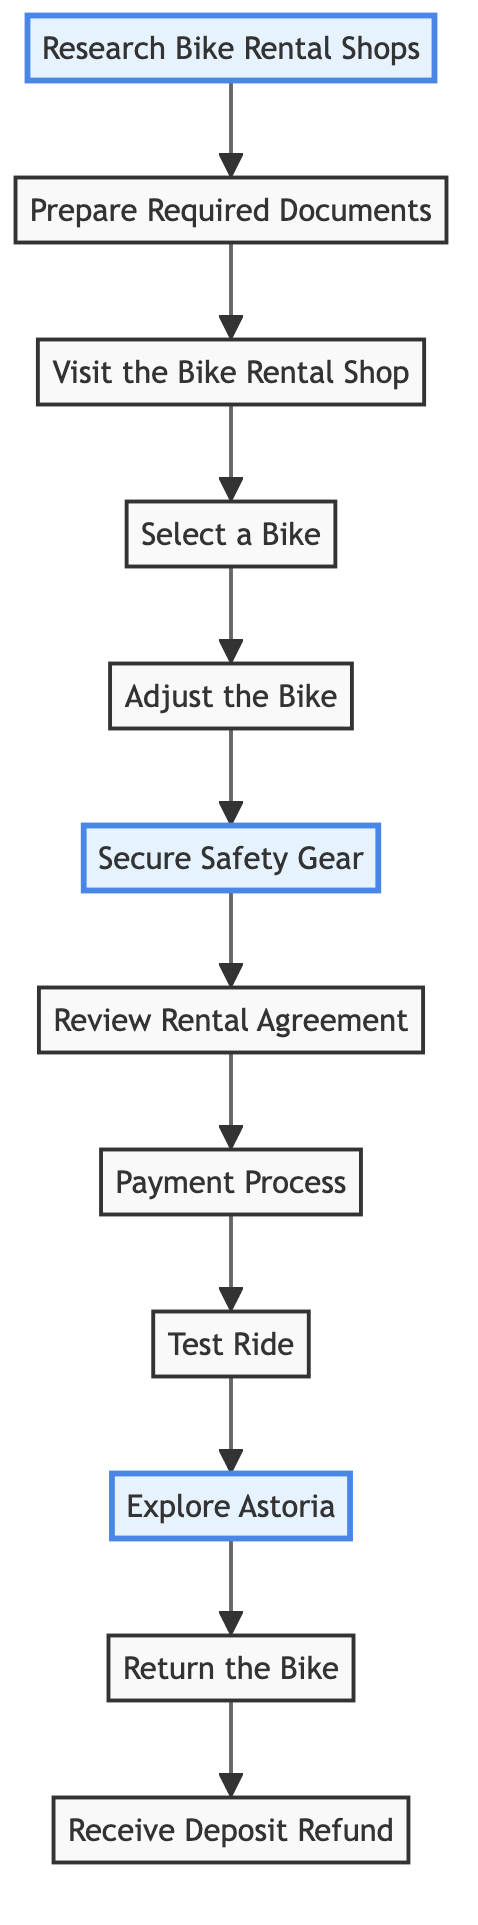How many nodes are in the diagram? There are 12 nodes in the diagram, each representing a step in the bike rental process.
Answer: 12 What is the first step in the process? The first step is 'Research Bike Rental Shops', which is the first node in the flow chart.
Answer: Research Bike Rental Shops Which step comes immediately after 'Prepare Required Documents'? The step that comes immediately after 'Prepare Required Documents' is 'Visit the Bike Rental Shop'.
Answer: Visit the Bike Rental Shop What is the last step in the rental process? The last step is 'Receive Deposit Refund', indicating that this is the final activity after returning the bike.
Answer: Receive Deposit Refund What step highlights safety gear? The highlighted step for safety gear is 'Secure Safety Gear', which emphasizes the importance of wearing a helmet.
Answer: Secure Safety Gear What are the two highlighted steps that involve exploring? The highlighted steps that involve exploring are 'Research Bike Rental Shops' and 'Explore Astoria', showing critical starting and ending points for the ride.
Answer: Research Bike Rental Shops, Explore Astoria Which two steps are directly connected without any intermediate steps? The two steps directly connected without any intermediate steps are 'Return the Bike' and 'Receive Deposit Refund', indicating a clear sequence of returning the bike and collecting the deposit.
Answer: Return the Bike, Receive Deposit Refund What is required before the 'Test Ride'? 'Payment Process' must be completed before the 'Test Ride', indicating that the payment has to be settled to proceed with testing the bike.
Answer: Payment Process What recommendation should you ask for while selecting a bike? You should ask for recommendations on easy-to-ride bikes suitable for beginners during the 'Select a Bike' step.
Answer: Recommendations on easy-to-ride bikes 